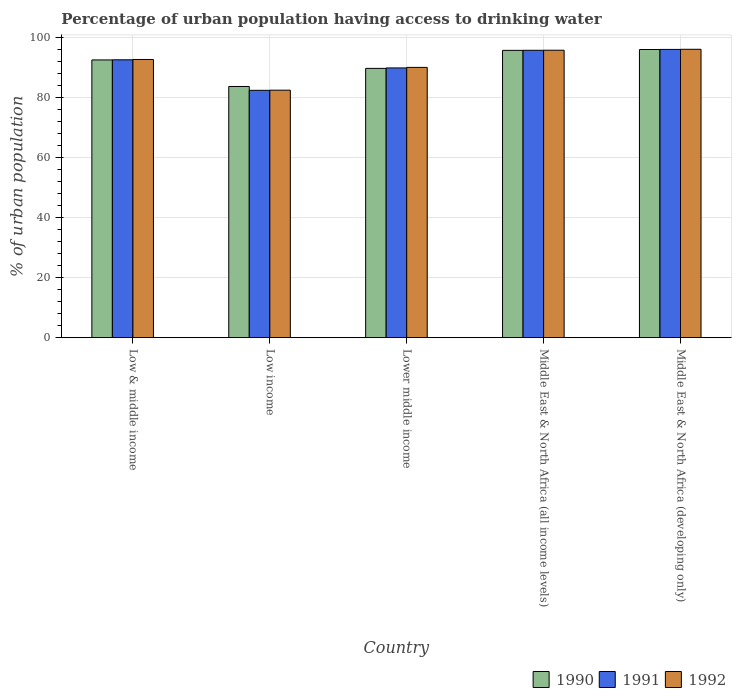How many different coloured bars are there?
Your response must be concise. 3. Are the number of bars on each tick of the X-axis equal?
Keep it short and to the point. Yes. How many bars are there on the 5th tick from the left?
Ensure brevity in your answer.  3. How many bars are there on the 3rd tick from the right?
Provide a succinct answer. 3. What is the label of the 1st group of bars from the left?
Offer a very short reply. Low & middle income. In how many cases, is the number of bars for a given country not equal to the number of legend labels?
Offer a very short reply. 0. What is the percentage of urban population having access to drinking water in 1991 in Middle East & North Africa (developing only)?
Provide a short and direct response. 96.11. Across all countries, what is the maximum percentage of urban population having access to drinking water in 1991?
Your response must be concise. 96.11. Across all countries, what is the minimum percentage of urban population having access to drinking water in 1991?
Your answer should be compact. 82.47. In which country was the percentage of urban population having access to drinking water in 1990 maximum?
Offer a terse response. Middle East & North Africa (developing only). What is the total percentage of urban population having access to drinking water in 1992 in the graph?
Provide a short and direct response. 457.4. What is the difference between the percentage of urban population having access to drinking water in 1991 in Low income and that in Middle East & North Africa (developing only)?
Ensure brevity in your answer.  -13.64. What is the difference between the percentage of urban population having access to drinking water in 1991 in Low income and the percentage of urban population having access to drinking water in 1990 in Low & middle income?
Ensure brevity in your answer.  -10.14. What is the average percentage of urban population having access to drinking water in 1990 per country?
Give a very brief answer. 91.61. What is the difference between the percentage of urban population having access to drinking water of/in 1991 and percentage of urban population having access to drinking water of/in 1990 in Low & middle income?
Your response must be concise. 0.04. In how many countries, is the percentage of urban population having access to drinking water in 1992 greater than 40 %?
Your response must be concise. 5. What is the ratio of the percentage of urban population having access to drinking water in 1991 in Low & middle income to that in Lower middle income?
Ensure brevity in your answer.  1.03. What is the difference between the highest and the second highest percentage of urban population having access to drinking water in 1992?
Ensure brevity in your answer.  3.39. What is the difference between the highest and the lowest percentage of urban population having access to drinking water in 1990?
Your response must be concise. 12.32. Is it the case that in every country, the sum of the percentage of urban population having access to drinking water in 1992 and percentage of urban population having access to drinking water in 1990 is greater than the percentage of urban population having access to drinking water in 1991?
Offer a terse response. Yes. Are all the bars in the graph horizontal?
Offer a very short reply. No. Are the values on the major ticks of Y-axis written in scientific E-notation?
Give a very brief answer. No. Does the graph contain grids?
Offer a very short reply. Yes. Where does the legend appear in the graph?
Your answer should be very brief. Bottom right. What is the title of the graph?
Keep it short and to the point. Percentage of urban population having access to drinking water. Does "1989" appear as one of the legend labels in the graph?
Your response must be concise. No. What is the label or title of the Y-axis?
Provide a succinct answer. % of urban population. What is the % of urban population of 1990 in Low & middle income?
Keep it short and to the point. 92.61. What is the % of urban population in 1991 in Low & middle income?
Give a very brief answer. 92.65. What is the % of urban population of 1992 in Low & middle income?
Your response must be concise. 92.76. What is the % of urban population in 1990 in Low income?
Offer a terse response. 83.76. What is the % of urban population of 1991 in Low income?
Your answer should be compact. 82.47. What is the % of urban population in 1992 in Low income?
Keep it short and to the point. 82.52. What is the % of urban population in 1990 in Lower middle income?
Keep it short and to the point. 89.79. What is the % of urban population in 1991 in Lower middle income?
Provide a succinct answer. 89.94. What is the % of urban population in 1992 in Lower middle income?
Offer a terse response. 90.12. What is the % of urban population in 1990 in Middle East & North Africa (all income levels)?
Give a very brief answer. 95.8. What is the % of urban population in 1991 in Middle East & North Africa (all income levels)?
Give a very brief answer. 95.82. What is the % of urban population in 1992 in Middle East & North Africa (all income levels)?
Offer a terse response. 95.85. What is the % of urban population of 1990 in Middle East & North Africa (developing only)?
Offer a very short reply. 96.08. What is the % of urban population in 1991 in Middle East & North Africa (developing only)?
Keep it short and to the point. 96.11. What is the % of urban population of 1992 in Middle East & North Africa (developing only)?
Offer a very short reply. 96.16. Across all countries, what is the maximum % of urban population of 1990?
Keep it short and to the point. 96.08. Across all countries, what is the maximum % of urban population of 1991?
Keep it short and to the point. 96.11. Across all countries, what is the maximum % of urban population in 1992?
Offer a terse response. 96.16. Across all countries, what is the minimum % of urban population in 1990?
Offer a terse response. 83.76. Across all countries, what is the minimum % of urban population in 1991?
Offer a very short reply. 82.47. Across all countries, what is the minimum % of urban population in 1992?
Ensure brevity in your answer.  82.52. What is the total % of urban population in 1990 in the graph?
Provide a succinct answer. 458.05. What is the total % of urban population of 1991 in the graph?
Make the answer very short. 457. What is the total % of urban population in 1992 in the graph?
Your answer should be compact. 457.4. What is the difference between the % of urban population in 1990 in Low & middle income and that in Low income?
Provide a short and direct response. 8.85. What is the difference between the % of urban population in 1991 in Low & middle income and that in Low income?
Ensure brevity in your answer.  10.18. What is the difference between the % of urban population in 1992 in Low & middle income and that in Low income?
Provide a short and direct response. 10.24. What is the difference between the % of urban population of 1990 in Low & middle income and that in Lower middle income?
Your answer should be very brief. 2.82. What is the difference between the % of urban population in 1991 in Low & middle income and that in Lower middle income?
Make the answer very short. 2.71. What is the difference between the % of urban population in 1992 in Low & middle income and that in Lower middle income?
Keep it short and to the point. 2.64. What is the difference between the % of urban population in 1990 in Low & middle income and that in Middle East & North Africa (all income levels)?
Offer a very short reply. -3.2. What is the difference between the % of urban population in 1991 in Low & middle income and that in Middle East & North Africa (all income levels)?
Ensure brevity in your answer.  -3.17. What is the difference between the % of urban population in 1992 in Low & middle income and that in Middle East & North Africa (all income levels)?
Give a very brief answer. -3.08. What is the difference between the % of urban population of 1990 in Low & middle income and that in Middle East & North Africa (developing only)?
Your answer should be compact. -3.48. What is the difference between the % of urban population of 1991 in Low & middle income and that in Middle East & North Africa (developing only)?
Give a very brief answer. -3.46. What is the difference between the % of urban population in 1992 in Low & middle income and that in Middle East & North Africa (developing only)?
Provide a short and direct response. -3.39. What is the difference between the % of urban population of 1990 in Low income and that in Lower middle income?
Provide a succinct answer. -6.03. What is the difference between the % of urban population in 1991 in Low income and that in Lower middle income?
Offer a very short reply. -7.47. What is the difference between the % of urban population in 1992 in Low income and that in Lower middle income?
Provide a succinct answer. -7.6. What is the difference between the % of urban population in 1990 in Low income and that in Middle East & North Africa (all income levels)?
Offer a very short reply. -12.04. What is the difference between the % of urban population of 1991 in Low income and that in Middle East & North Africa (all income levels)?
Ensure brevity in your answer.  -13.35. What is the difference between the % of urban population in 1992 in Low income and that in Middle East & North Africa (all income levels)?
Offer a terse response. -13.32. What is the difference between the % of urban population in 1990 in Low income and that in Middle East & North Africa (developing only)?
Your response must be concise. -12.32. What is the difference between the % of urban population in 1991 in Low income and that in Middle East & North Africa (developing only)?
Your answer should be very brief. -13.64. What is the difference between the % of urban population of 1992 in Low income and that in Middle East & North Africa (developing only)?
Offer a very short reply. -13.63. What is the difference between the % of urban population of 1990 in Lower middle income and that in Middle East & North Africa (all income levels)?
Offer a very short reply. -6.01. What is the difference between the % of urban population in 1991 in Lower middle income and that in Middle East & North Africa (all income levels)?
Keep it short and to the point. -5.88. What is the difference between the % of urban population in 1992 in Lower middle income and that in Middle East & North Africa (all income levels)?
Your answer should be very brief. -5.73. What is the difference between the % of urban population in 1990 in Lower middle income and that in Middle East & North Africa (developing only)?
Your response must be concise. -6.29. What is the difference between the % of urban population of 1991 in Lower middle income and that in Middle East & North Africa (developing only)?
Ensure brevity in your answer.  -6.17. What is the difference between the % of urban population in 1992 in Lower middle income and that in Middle East & North Africa (developing only)?
Your response must be concise. -6.04. What is the difference between the % of urban population of 1990 in Middle East & North Africa (all income levels) and that in Middle East & North Africa (developing only)?
Keep it short and to the point. -0.28. What is the difference between the % of urban population in 1991 in Middle East & North Africa (all income levels) and that in Middle East & North Africa (developing only)?
Make the answer very short. -0.29. What is the difference between the % of urban population of 1992 in Middle East & North Africa (all income levels) and that in Middle East & North Africa (developing only)?
Ensure brevity in your answer.  -0.31. What is the difference between the % of urban population of 1990 in Low & middle income and the % of urban population of 1991 in Low income?
Ensure brevity in your answer.  10.14. What is the difference between the % of urban population in 1990 in Low & middle income and the % of urban population in 1992 in Low income?
Offer a very short reply. 10.09. What is the difference between the % of urban population in 1991 in Low & middle income and the % of urban population in 1992 in Low income?
Your answer should be compact. 10.13. What is the difference between the % of urban population in 1990 in Low & middle income and the % of urban population in 1991 in Lower middle income?
Your answer should be very brief. 2.67. What is the difference between the % of urban population of 1990 in Low & middle income and the % of urban population of 1992 in Lower middle income?
Your answer should be compact. 2.49. What is the difference between the % of urban population of 1991 in Low & middle income and the % of urban population of 1992 in Lower middle income?
Your response must be concise. 2.53. What is the difference between the % of urban population of 1990 in Low & middle income and the % of urban population of 1991 in Middle East & North Africa (all income levels)?
Give a very brief answer. -3.22. What is the difference between the % of urban population of 1990 in Low & middle income and the % of urban population of 1992 in Middle East & North Africa (all income levels)?
Your answer should be very brief. -3.24. What is the difference between the % of urban population of 1991 in Low & middle income and the % of urban population of 1992 in Middle East & North Africa (all income levels)?
Keep it short and to the point. -3.2. What is the difference between the % of urban population of 1990 in Low & middle income and the % of urban population of 1991 in Middle East & North Africa (developing only)?
Offer a very short reply. -3.5. What is the difference between the % of urban population in 1990 in Low & middle income and the % of urban population in 1992 in Middle East & North Africa (developing only)?
Your answer should be compact. -3.55. What is the difference between the % of urban population in 1991 in Low & middle income and the % of urban population in 1992 in Middle East & North Africa (developing only)?
Offer a terse response. -3.51. What is the difference between the % of urban population of 1990 in Low income and the % of urban population of 1991 in Lower middle income?
Provide a short and direct response. -6.18. What is the difference between the % of urban population in 1990 in Low income and the % of urban population in 1992 in Lower middle income?
Your answer should be compact. -6.36. What is the difference between the % of urban population in 1991 in Low income and the % of urban population in 1992 in Lower middle income?
Your answer should be very brief. -7.64. What is the difference between the % of urban population in 1990 in Low income and the % of urban population in 1991 in Middle East & North Africa (all income levels)?
Give a very brief answer. -12.06. What is the difference between the % of urban population in 1990 in Low income and the % of urban population in 1992 in Middle East & North Africa (all income levels)?
Provide a short and direct response. -12.09. What is the difference between the % of urban population in 1991 in Low income and the % of urban population in 1992 in Middle East & North Africa (all income levels)?
Give a very brief answer. -13.37. What is the difference between the % of urban population of 1990 in Low income and the % of urban population of 1991 in Middle East & North Africa (developing only)?
Offer a terse response. -12.35. What is the difference between the % of urban population of 1990 in Low income and the % of urban population of 1992 in Middle East & North Africa (developing only)?
Make the answer very short. -12.4. What is the difference between the % of urban population in 1991 in Low income and the % of urban population in 1992 in Middle East & North Africa (developing only)?
Your answer should be very brief. -13.68. What is the difference between the % of urban population in 1990 in Lower middle income and the % of urban population in 1991 in Middle East & North Africa (all income levels)?
Give a very brief answer. -6.03. What is the difference between the % of urban population in 1990 in Lower middle income and the % of urban population in 1992 in Middle East & North Africa (all income levels)?
Make the answer very short. -6.05. What is the difference between the % of urban population in 1991 in Lower middle income and the % of urban population in 1992 in Middle East & North Africa (all income levels)?
Your answer should be very brief. -5.91. What is the difference between the % of urban population in 1990 in Lower middle income and the % of urban population in 1991 in Middle East & North Africa (developing only)?
Offer a terse response. -6.32. What is the difference between the % of urban population of 1990 in Lower middle income and the % of urban population of 1992 in Middle East & North Africa (developing only)?
Your response must be concise. -6.36. What is the difference between the % of urban population in 1991 in Lower middle income and the % of urban population in 1992 in Middle East & North Africa (developing only)?
Offer a very short reply. -6.22. What is the difference between the % of urban population in 1990 in Middle East & North Africa (all income levels) and the % of urban population in 1991 in Middle East & North Africa (developing only)?
Offer a terse response. -0.31. What is the difference between the % of urban population in 1990 in Middle East & North Africa (all income levels) and the % of urban population in 1992 in Middle East & North Africa (developing only)?
Offer a terse response. -0.35. What is the difference between the % of urban population of 1991 in Middle East & North Africa (all income levels) and the % of urban population of 1992 in Middle East & North Africa (developing only)?
Offer a terse response. -0.33. What is the average % of urban population in 1990 per country?
Ensure brevity in your answer.  91.61. What is the average % of urban population of 1991 per country?
Offer a very short reply. 91.4. What is the average % of urban population of 1992 per country?
Your answer should be very brief. 91.48. What is the difference between the % of urban population of 1990 and % of urban population of 1991 in Low & middle income?
Provide a short and direct response. -0.04. What is the difference between the % of urban population of 1990 and % of urban population of 1992 in Low & middle income?
Provide a short and direct response. -0.15. What is the difference between the % of urban population in 1991 and % of urban population in 1992 in Low & middle income?
Keep it short and to the point. -0.11. What is the difference between the % of urban population of 1990 and % of urban population of 1991 in Low income?
Your answer should be compact. 1.29. What is the difference between the % of urban population of 1990 and % of urban population of 1992 in Low income?
Offer a very short reply. 1.24. What is the difference between the % of urban population in 1991 and % of urban population in 1992 in Low income?
Ensure brevity in your answer.  -0.05. What is the difference between the % of urban population in 1990 and % of urban population in 1991 in Lower middle income?
Your response must be concise. -0.15. What is the difference between the % of urban population in 1990 and % of urban population in 1992 in Lower middle income?
Provide a short and direct response. -0.33. What is the difference between the % of urban population of 1991 and % of urban population of 1992 in Lower middle income?
Ensure brevity in your answer.  -0.18. What is the difference between the % of urban population of 1990 and % of urban population of 1991 in Middle East & North Africa (all income levels)?
Give a very brief answer. -0.02. What is the difference between the % of urban population of 1990 and % of urban population of 1992 in Middle East & North Africa (all income levels)?
Make the answer very short. -0.04. What is the difference between the % of urban population of 1991 and % of urban population of 1992 in Middle East & North Africa (all income levels)?
Make the answer very short. -0.02. What is the difference between the % of urban population in 1990 and % of urban population in 1991 in Middle East & North Africa (developing only)?
Offer a very short reply. -0.03. What is the difference between the % of urban population of 1990 and % of urban population of 1992 in Middle East & North Africa (developing only)?
Ensure brevity in your answer.  -0.07. What is the difference between the % of urban population in 1991 and % of urban population in 1992 in Middle East & North Africa (developing only)?
Offer a very short reply. -0.04. What is the ratio of the % of urban population in 1990 in Low & middle income to that in Low income?
Provide a succinct answer. 1.11. What is the ratio of the % of urban population in 1991 in Low & middle income to that in Low income?
Your answer should be compact. 1.12. What is the ratio of the % of urban population of 1992 in Low & middle income to that in Low income?
Ensure brevity in your answer.  1.12. What is the ratio of the % of urban population in 1990 in Low & middle income to that in Lower middle income?
Your answer should be compact. 1.03. What is the ratio of the % of urban population in 1991 in Low & middle income to that in Lower middle income?
Give a very brief answer. 1.03. What is the ratio of the % of urban population of 1992 in Low & middle income to that in Lower middle income?
Your answer should be very brief. 1.03. What is the ratio of the % of urban population of 1990 in Low & middle income to that in Middle East & North Africa (all income levels)?
Your answer should be very brief. 0.97. What is the ratio of the % of urban population in 1991 in Low & middle income to that in Middle East & North Africa (all income levels)?
Provide a short and direct response. 0.97. What is the ratio of the % of urban population of 1992 in Low & middle income to that in Middle East & North Africa (all income levels)?
Make the answer very short. 0.97. What is the ratio of the % of urban population in 1990 in Low & middle income to that in Middle East & North Africa (developing only)?
Offer a terse response. 0.96. What is the ratio of the % of urban population in 1992 in Low & middle income to that in Middle East & North Africa (developing only)?
Your answer should be very brief. 0.96. What is the ratio of the % of urban population of 1990 in Low income to that in Lower middle income?
Offer a very short reply. 0.93. What is the ratio of the % of urban population in 1991 in Low income to that in Lower middle income?
Provide a succinct answer. 0.92. What is the ratio of the % of urban population in 1992 in Low income to that in Lower middle income?
Your answer should be very brief. 0.92. What is the ratio of the % of urban population of 1990 in Low income to that in Middle East & North Africa (all income levels)?
Provide a succinct answer. 0.87. What is the ratio of the % of urban population of 1991 in Low income to that in Middle East & North Africa (all income levels)?
Offer a terse response. 0.86. What is the ratio of the % of urban population in 1992 in Low income to that in Middle East & North Africa (all income levels)?
Your answer should be very brief. 0.86. What is the ratio of the % of urban population in 1990 in Low income to that in Middle East & North Africa (developing only)?
Your response must be concise. 0.87. What is the ratio of the % of urban population of 1991 in Low income to that in Middle East & North Africa (developing only)?
Give a very brief answer. 0.86. What is the ratio of the % of urban population of 1992 in Low income to that in Middle East & North Africa (developing only)?
Make the answer very short. 0.86. What is the ratio of the % of urban population in 1990 in Lower middle income to that in Middle East & North Africa (all income levels)?
Offer a very short reply. 0.94. What is the ratio of the % of urban population in 1991 in Lower middle income to that in Middle East & North Africa (all income levels)?
Your answer should be very brief. 0.94. What is the ratio of the % of urban population of 1992 in Lower middle income to that in Middle East & North Africa (all income levels)?
Your answer should be very brief. 0.94. What is the ratio of the % of urban population in 1990 in Lower middle income to that in Middle East & North Africa (developing only)?
Your answer should be compact. 0.93. What is the ratio of the % of urban population of 1991 in Lower middle income to that in Middle East & North Africa (developing only)?
Offer a terse response. 0.94. What is the ratio of the % of urban population in 1992 in Lower middle income to that in Middle East & North Africa (developing only)?
Offer a terse response. 0.94. What is the ratio of the % of urban population of 1991 in Middle East & North Africa (all income levels) to that in Middle East & North Africa (developing only)?
Offer a very short reply. 1. What is the ratio of the % of urban population in 1992 in Middle East & North Africa (all income levels) to that in Middle East & North Africa (developing only)?
Provide a succinct answer. 1. What is the difference between the highest and the second highest % of urban population of 1990?
Make the answer very short. 0.28. What is the difference between the highest and the second highest % of urban population of 1991?
Provide a short and direct response. 0.29. What is the difference between the highest and the second highest % of urban population in 1992?
Your response must be concise. 0.31. What is the difference between the highest and the lowest % of urban population of 1990?
Offer a very short reply. 12.32. What is the difference between the highest and the lowest % of urban population of 1991?
Provide a succinct answer. 13.64. What is the difference between the highest and the lowest % of urban population in 1992?
Provide a short and direct response. 13.63. 